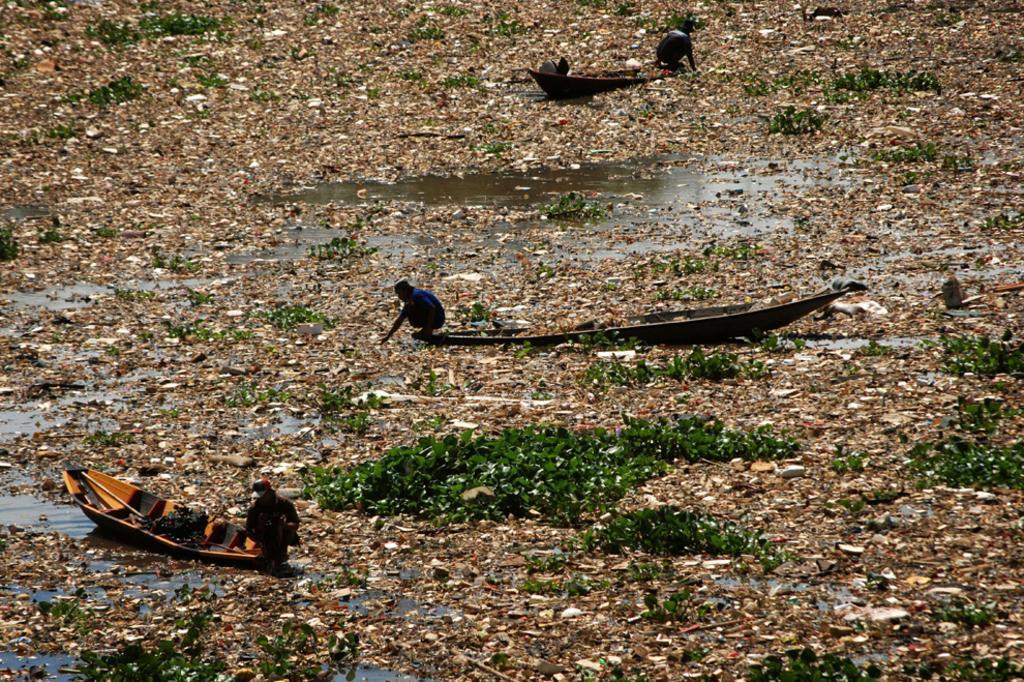How would you summarize this image in a sentence or two? In this image we can see the people in the boats. And we can see the garbage. And we can see the water and plants. 